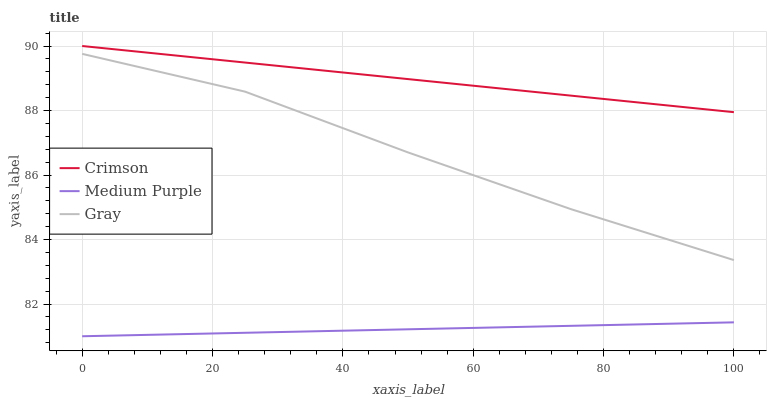Does Medium Purple have the minimum area under the curve?
Answer yes or no. Yes. Does Crimson have the maximum area under the curve?
Answer yes or no. Yes. Does Gray have the minimum area under the curve?
Answer yes or no. No. Does Gray have the maximum area under the curve?
Answer yes or no. No. Is Crimson the smoothest?
Answer yes or no. Yes. Is Gray the roughest?
Answer yes or no. Yes. Is Gray the smoothest?
Answer yes or no. No. Is Medium Purple the roughest?
Answer yes or no. No. Does Medium Purple have the lowest value?
Answer yes or no. Yes. Does Gray have the lowest value?
Answer yes or no. No. Does Crimson have the highest value?
Answer yes or no. Yes. Does Gray have the highest value?
Answer yes or no. No. Is Medium Purple less than Gray?
Answer yes or no. Yes. Is Gray greater than Medium Purple?
Answer yes or no. Yes. Does Medium Purple intersect Gray?
Answer yes or no. No. 